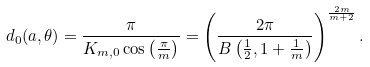<formula> <loc_0><loc_0><loc_500><loc_500>d _ { 0 } ( { a } , \theta ) = \frac { \pi } { K _ { m , 0 } \cos \left ( \frac { \pi } { m } \right ) } = \left ( \frac { 2 \pi } { B \left ( \frac { 1 } { 2 } , 1 + \frac { 1 } { m } \right ) } \right ) ^ { \frac { 2 m } { m + 2 } } .</formula> 